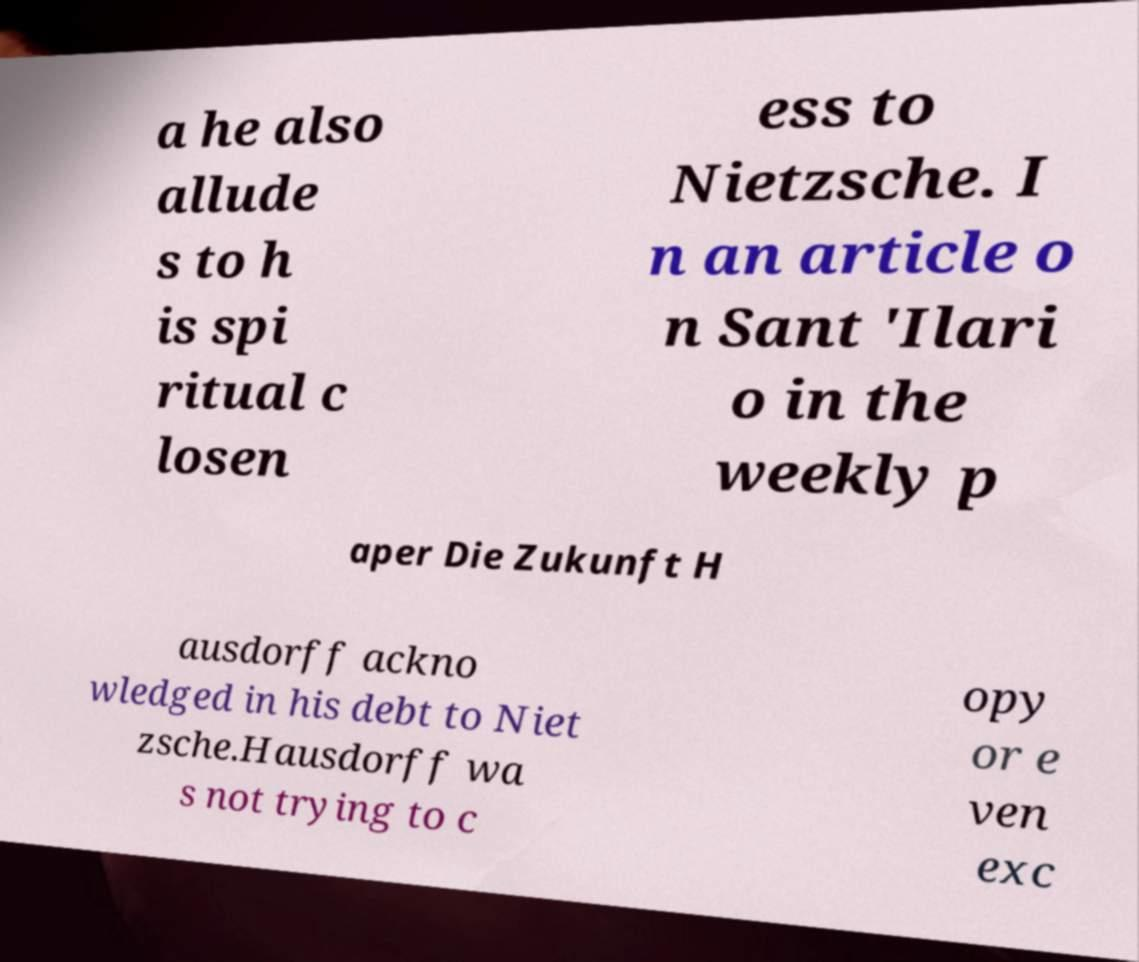Could you extract and type out the text from this image? a he also allude s to h is spi ritual c losen ess to Nietzsche. I n an article o n Sant 'Ilari o in the weekly p aper Die Zukunft H ausdorff ackno wledged in his debt to Niet zsche.Hausdorff wa s not trying to c opy or e ven exc 